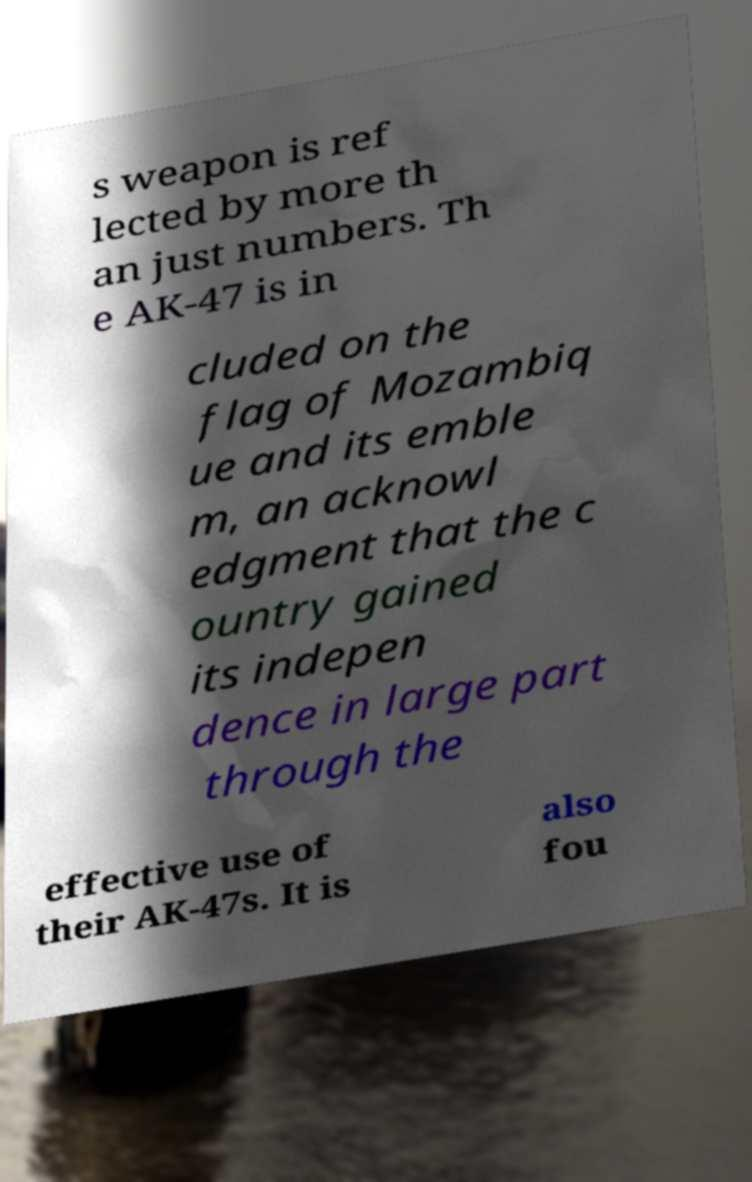Can you accurately transcribe the text from the provided image for me? s weapon is ref lected by more th an just numbers. Th e AK-47 is in cluded on the flag of Mozambiq ue and its emble m, an acknowl edgment that the c ountry gained its indepen dence in large part through the effective use of their AK-47s. It is also fou 